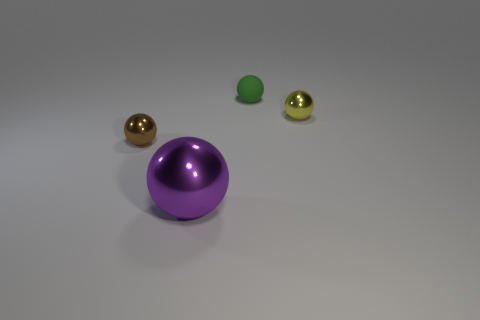Subtract 1 spheres. How many spheres are left? 3 Add 2 yellow objects. How many objects exist? 6 Add 3 brown objects. How many brown objects exist? 4 Subtract 0 gray spheres. How many objects are left? 4 Subtract all balls. Subtract all small green metallic cubes. How many objects are left? 0 Add 3 tiny spheres. How many tiny spheres are left? 6 